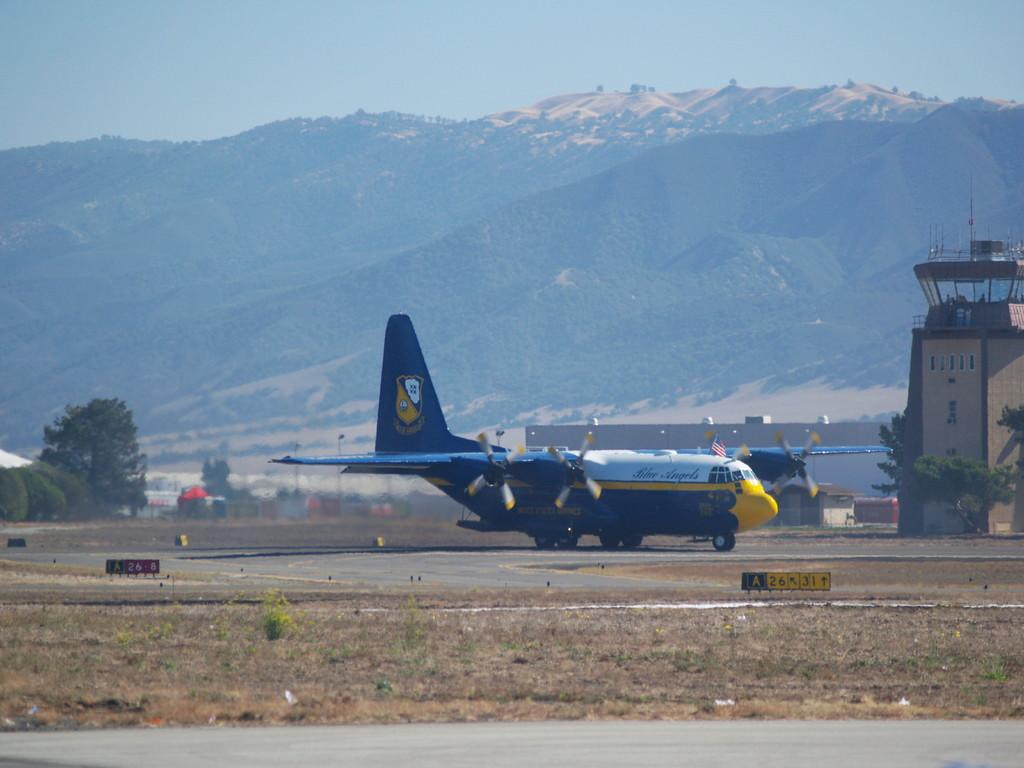What is the main subject of the picture? The main subject of the picture is an aircraft. What other elements can be seen in the picture? There are trees, a road, and a hill visible in the picture. What is visible in the sky? Clouds are visible in the sky. What type of insect can be seen crawling on the hour in the image? There is no insect or hour present in the image; it features an aircraft, trees, a road, a hill, and clouds in the sky. 